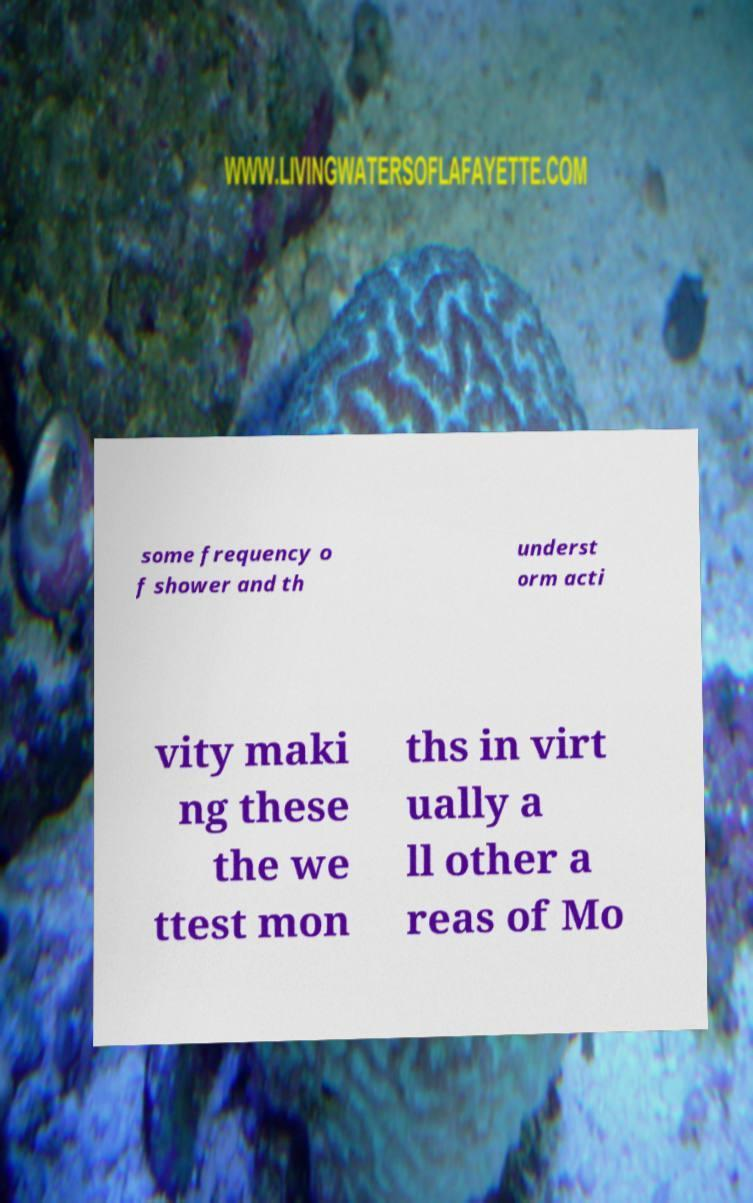For documentation purposes, I need the text within this image transcribed. Could you provide that? some frequency o f shower and th underst orm acti vity maki ng these the we ttest mon ths in virt ually a ll other a reas of Mo 